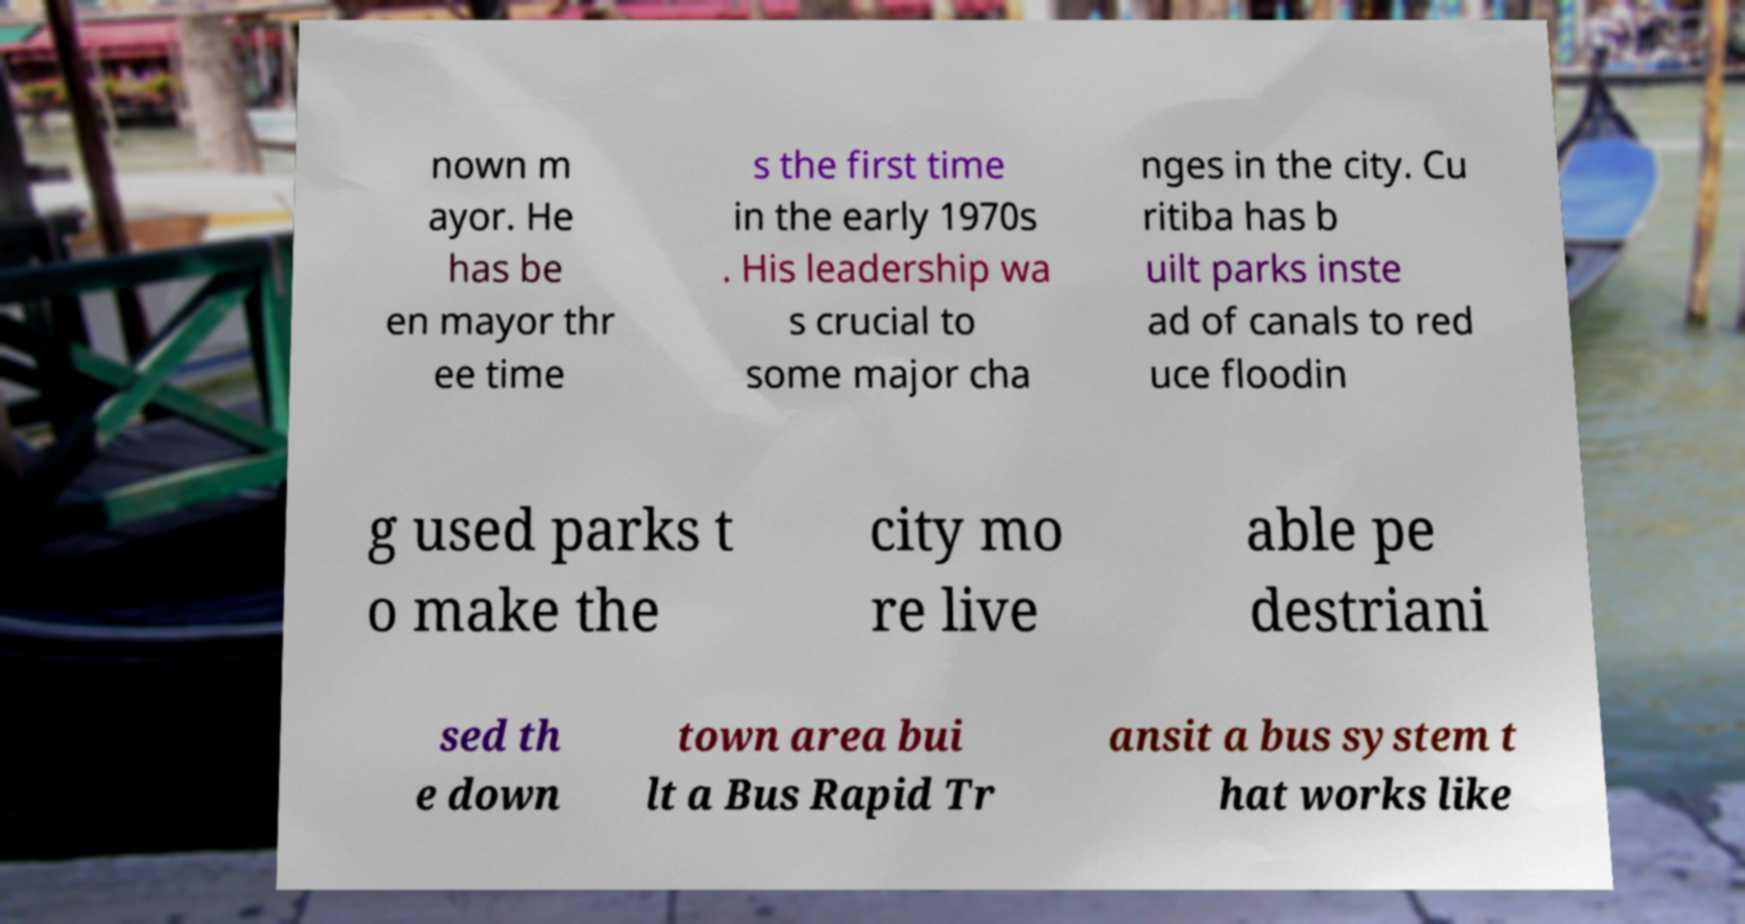Could you assist in decoding the text presented in this image and type it out clearly? nown m ayor. He has be en mayor thr ee time s the first time in the early 1970s . His leadership wa s crucial to some major cha nges in the city. Cu ritiba has b uilt parks inste ad of canals to red uce floodin g used parks t o make the city mo re live able pe destriani sed th e down town area bui lt a Bus Rapid Tr ansit a bus system t hat works like 